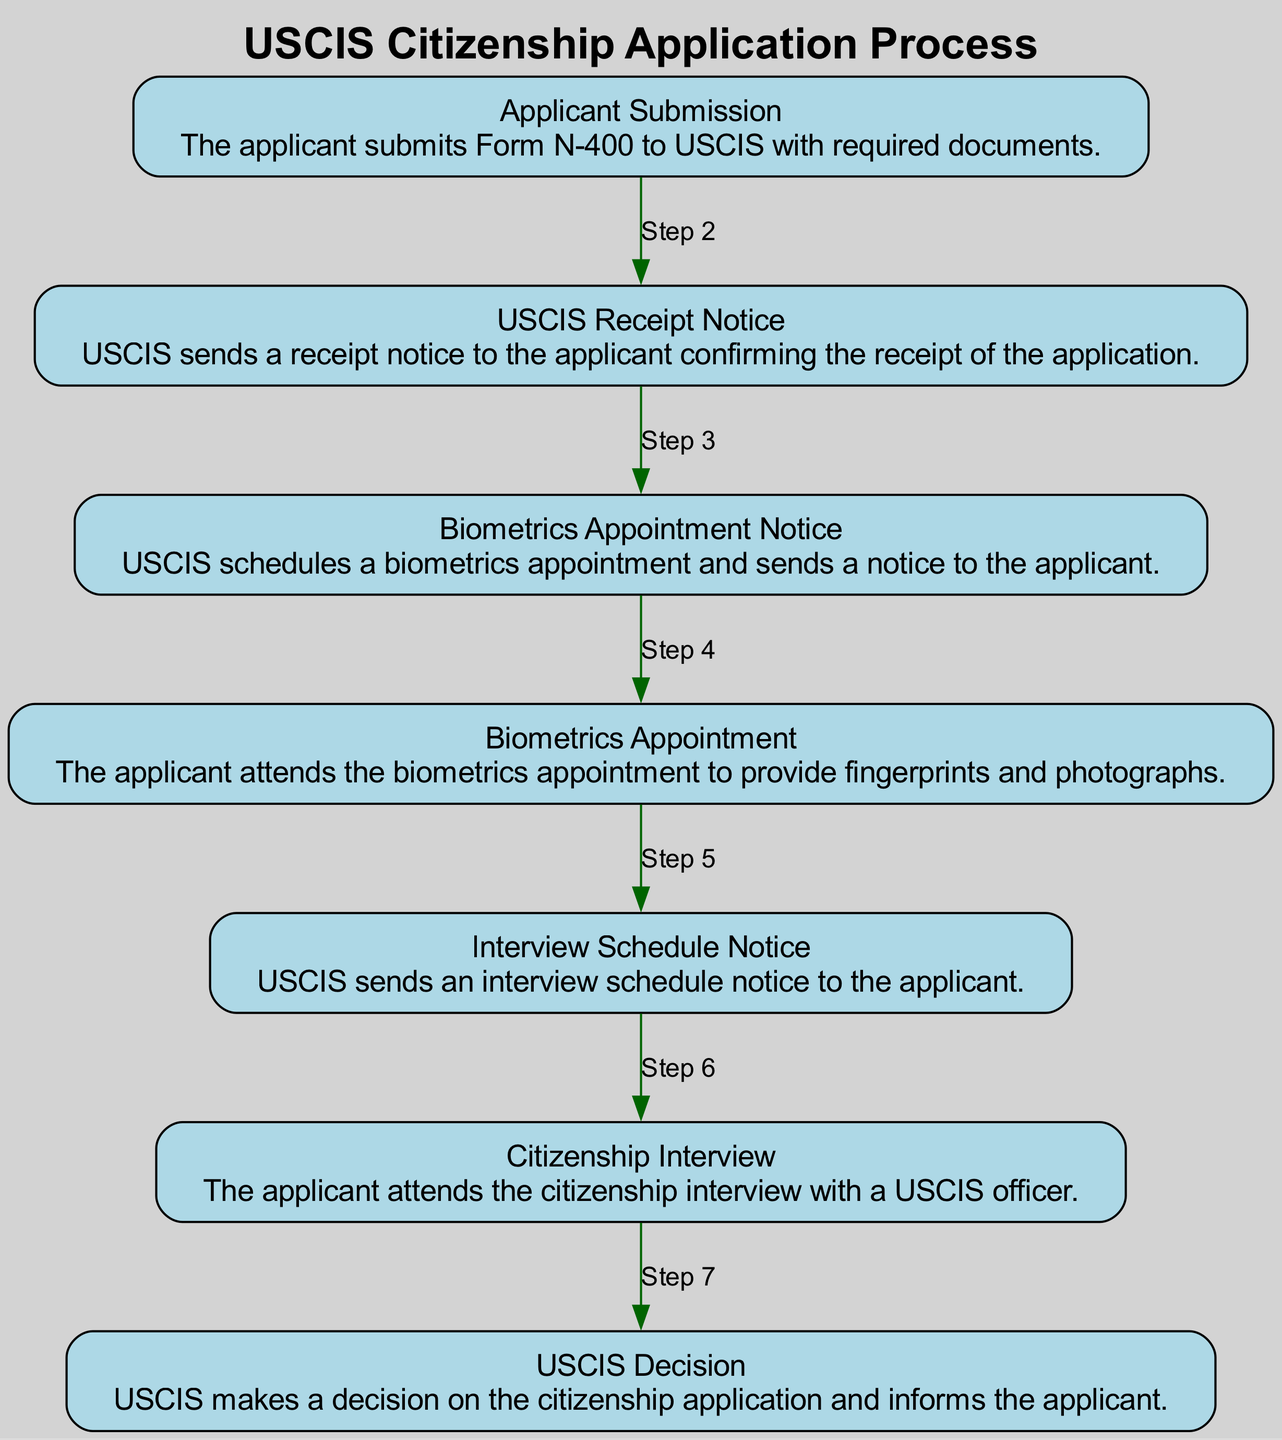What is the first step in the citizenship application process? The diagram indicates that the first step in the process is the "Applicant Submission," where the applicant submits Form N-400 to USCIS with required documents.
Answer: Applicant Submission How many main steps are shown in the diagram? By counting each node (step) in the diagram, we see that there are a total of seven main steps in the citizenship application process.
Answer: Seven What does USCIS send to the applicant after they submit their application? The diagram specifies that USCIS sends a "Receipt Notice" to the applicant, confirming the receipt of the application after submission.
Answer: Receipt Notice What step follows the biometrics appointment? After the "Biometrics Appointment," the next step shown in the diagram is the "Interview Schedule Notice," indicating that USCIS then sends the applicant an interview schedule notice.
Answer: Interview Schedule Notice How does the process proceed after the "Citizenship Interview"? The next step in the process after the "Citizenship Interview" is the "USCIS Decision," where USCIS makes a decision on the citizenship application and informs the applicant.
Answer: USCIS Decision What step comes before the "Citizenship Interview"? According to the diagram, the step that comes before the "Citizenship Interview" is the "Interview Schedule Notice," where USCIS notifies the applicant about the scheduled interview.
Answer: Interview Schedule Notice Which node directly leads to the "USCIS Decision"? The "Citizenship Interview" directly leads to the "USCIS Decision," as indicated by the flow of the diagram, showing that the interview is a prerequisite for the decision.
Answer: Citizenship Interview What type of notice is sent after the applicant provides biometrics? After the biometrics appointment, the "Interview Schedule Notice" is sent to the applicant, according to the sequence in the diagram.
Answer: Interview Schedule Notice 